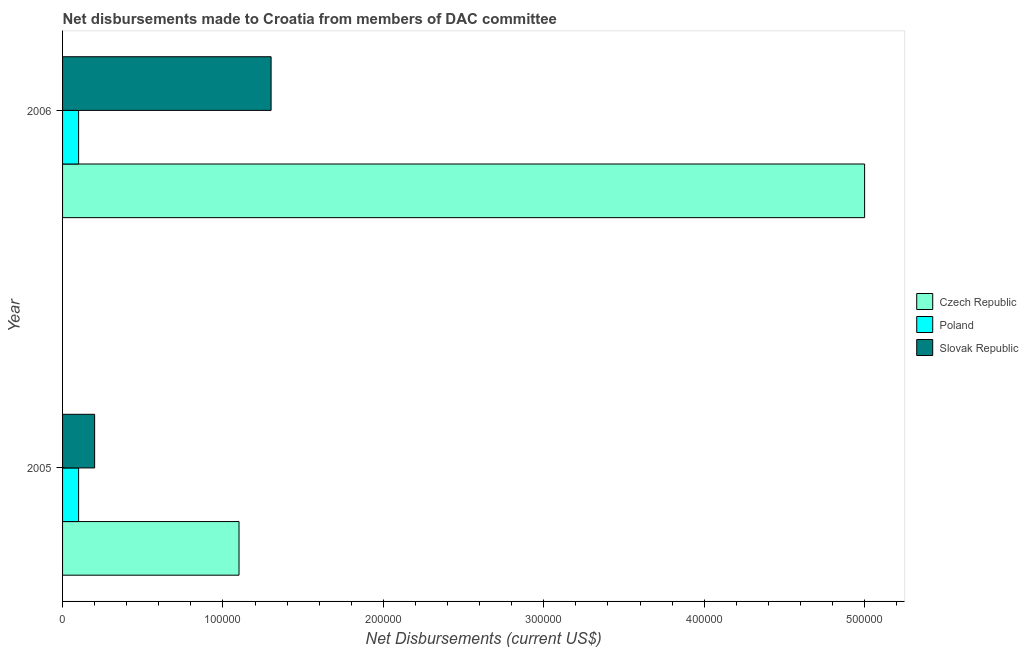How many bars are there on the 2nd tick from the bottom?
Ensure brevity in your answer.  3. In how many cases, is the number of bars for a given year not equal to the number of legend labels?
Keep it short and to the point. 0. What is the net disbursements made by slovak republic in 2006?
Offer a very short reply. 1.30e+05. Across all years, what is the maximum net disbursements made by poland?
Provide a succinct answer. 10000. Across all years, what is the minimum net disbursements made by czech republic?
Your response must be concise. 1.10e+05. In which year was the net disbursements made by slovak republic maximum?
Offer a terse response. 2006. In which year was the net disbursements made by poland minimum?
Offer a very short reply. 2005. What is the total net disbursements made by poland in the graph?
Provide a succinct answer. 2.00e+04. What is the difference between the net disbursements made by czech republic in 2006 and the net disbursements made by poland in 2005?
Offer a very short reply. 4.90e+05. What is the average net disbursements made by slovak republic per year?
Provide a succinct answer. 7.50e+04. In the year 2005, what is the difference between the net disbursements made by slovak republic and net disbursements made by czech republic?
Your answer should be very brief. -9.00e+04. What is the ratio of the net disbursements made by slovak republic in 2005 to that in 2006?
Make the answer very short. 0.15. In how many years, is the net disbursements made by slovak republic greater than the average net disbursements made by slovak republic taken over all years?
Offer a very short reply. 1. What does the 3rd bar from the top in 2005 represents?
Provide a succinct answer. Czech Republic. What does the 1st bar from the bottom in 2006 represents?
Your answer should be very brief. Czech Republic. Are all the bars in the graph horizontal?
Your response must be concise. Yes. How many years are there in the graph?
Your answer should be very brief. 2. Are the values on the major ticks of X-axis written in scientific E-notation?
Give a very brief answer. No. Does the graph contain any zero values?
Your answer should be compact. No. Does the graph contain grids?
Offer a very short reply. No. How many legend labels are there?
Your response must be concise. 3. What is the title of the graph?
Ensure brevity in your answer.  Net disbursements made to Croatia from members of DAC committee. What is the label or title of the X-axis?
Make the answer very short. Net Disbursements (current US$). What is the label or title of the Y-axis?
Your response must be concise. Year. What is the Net Disbursements (current US$) of Czech Republic in 2005?
Ensure brevity in your answer.  1.10e+05. What is the Net Disbursements (current US$) in Poland in 2005?
Your response must be concise. 10000. What is the Net Disbursements (current US$) of Slovak Republic in 2006?
Give a very brief answer. 1.30e+05. Across all years, what is the maximum Net Disbursements (current US$) of Czech Republic?
Your answer should be compact. 5.00e+05. Across all years, what is the maximum Net Disbursements (current US$) in Poland?
Your answer should be compact. 10000. Across all years, what is the maximum Net Disbursements (current US$) in Slovak Republic?
Keep it short and to the point. 1.30e+05. Across all years, what is the minimum Net Disbursements (current US$) in Slovak Republic?
Offer a terse response. 2.00e+04. What is the difference between the Net Disbursements (current US$) of Czech Republic in 2005 and that in 2006?
Your answer should be compact. -3.90e+05. What is the difference between the Net Disbursements (current US$) of Slovak Republic in 2005 and that in 2006?
Provide a succinct answer. -1.10e+05. What is the difference between the Net Disbursements (current US$) of Poland in 2005 and the Net Disbursements (current US$) of Slovak Republic in 2006?
Your answer should be compact. -1.20e+05. What is the average Net Disbursements (current US$) of Czech Republic per year?
Your answer should be compact. 3.05e+05. What is the average Net Disbursements (current US$) in Poland per year?
Offer a very short reply. 10000. What is the average Net Disbursements (current US$) of Slovak Republic per year?
Offer a very short reply. 7.50e+04. In the year 2005, what is the difference between the Net Disbursements (current US$) of Czech Republic and Net Disbursements (current US$) of Poland?
Your answer should be compact. 1.00e+05. In the year 2006, what is the difference between the Net Disbursements (current US$) of Czech Republic and Net Disbursements (current US$) of Poland?
Give a very brief answer. 4.90e+05. What is the ratio of the Net Disbursements (current US$) of Czech Republic in 2005 to that in 2006?
Ensure brevity in your answer.  0.22. What is the ratio of the Net Disbursements (current US$) of Poland in 2005 to that in 2006?
Provide a short and direct response. 1. What is the ratio of the Net Disbursements (current US$) in Slovak Republic in 2005 to that in 2006?
Offer a very short reply. 0.15. What is the difference between the highest and the second highest Net Disbursements (current US$) of Czech Republic?
Provide a succinct answer. 3.90e+05. What is the difference between the highest and the second highest Net Disbursements (current US$) of Poland?
Your answer should be compact. 0. What is the difference between the highest and the second highest Net Disbursements (current US$) in Slovak Republic?
Offer a terse response. 1.10e+05. What is the difference between the highest and the lowest Net Disbursements (current US$) of Czech Republic?
Your answer should be very brief. 3.90e+05. What is the difference between the highest and the lowest Net Disbursements (current US$) in Poland?
Make the answer very short. 0. 